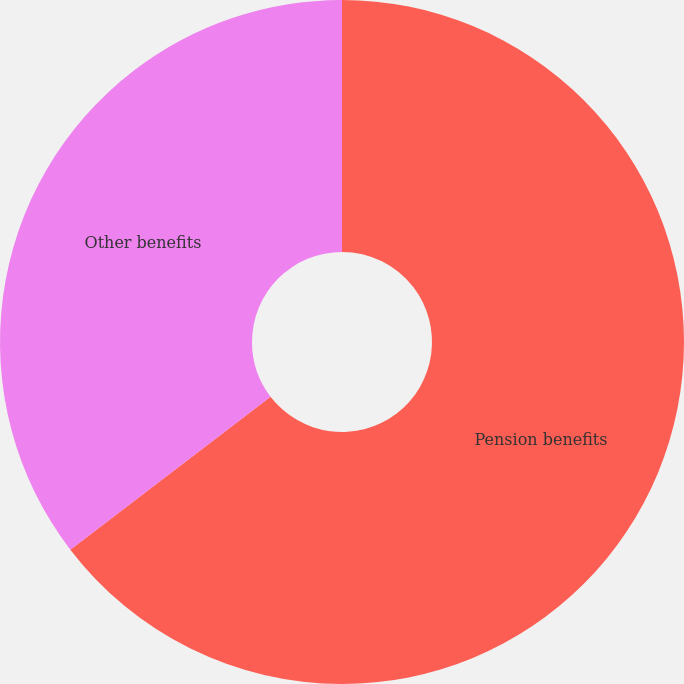Convert chart to OTSL. <chart><loc_0><loc_0><loc_500><loc_500><pie_chart><fcel>Pension benefits<fcel>Other benefits<nl><fcel>64.61%<fcel>35.39%<nl></chart> 